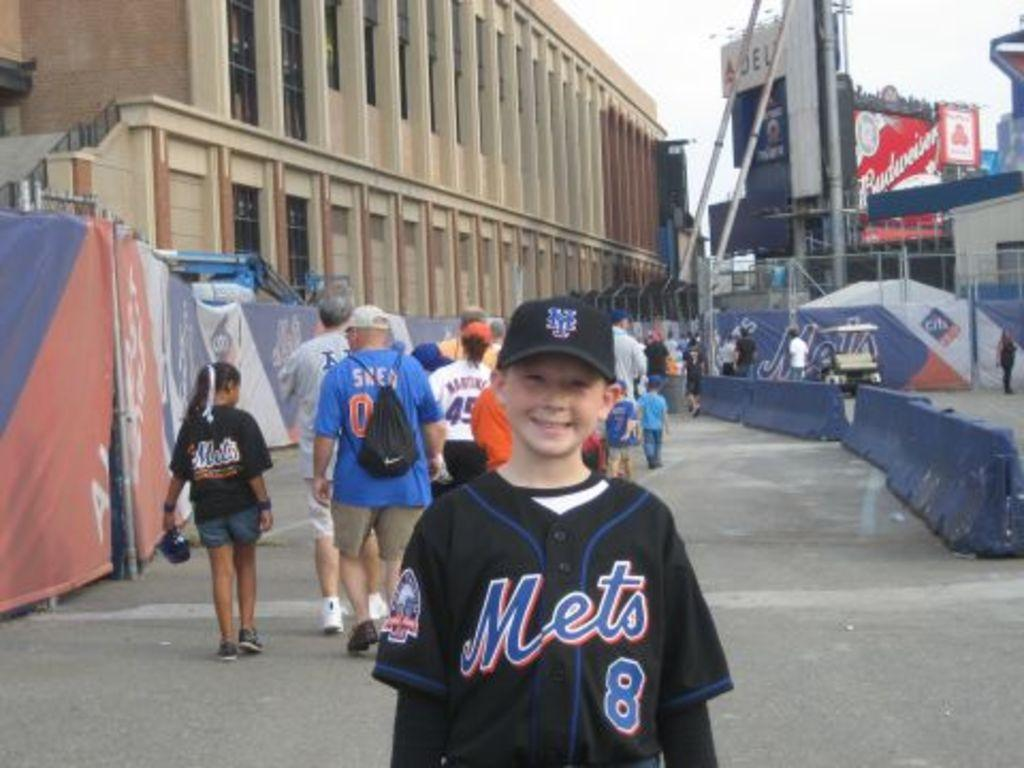<image>
Offer a succinct explanation of the picture presented. Boy wearing a black Mets jersey standing and posing for a photo. 